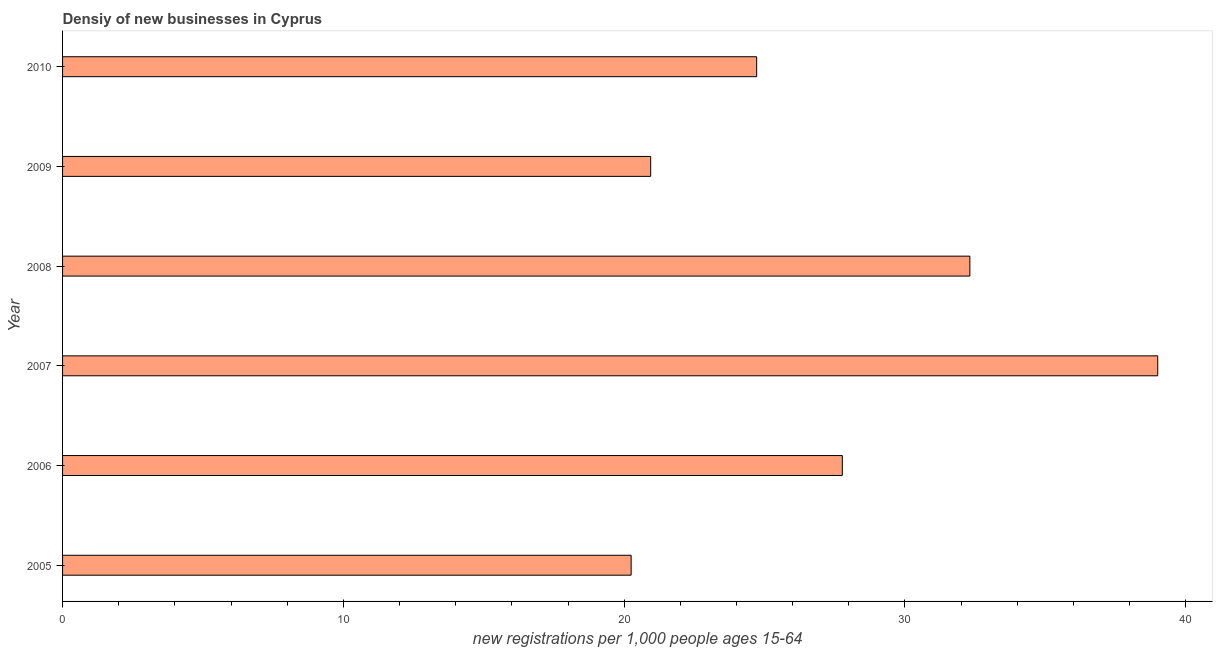What is the title of the graph?
Provide a short and direct response. Densiy of new businesses in Cyprus. What is the label or title of the X-axis?
Your answer should be compact. New registrations per 1,0 people ages 15-64. What is the label or title of the Y-axis?
Offer a terse response. Year. What is the density of new business in 2008?
Provide a succinct answer. 32.31. Across all years, what is the maximum density of new business?
Your response must be concise. 39. Across all years, what is the minimum density of new business?
Your answer should be compact. 20.25. What is the sum of the density of new business?
Your response must be concise. 164.99. What is the difference between the density of new business in 2005 and 2006?
Provide a succinct answer. -7.52. What is the average density of new business per year?
Offer a terse response. 27.5. What is the median density of new business?
Provide a short and direct response. 26.24. What is the ratio of the density of new business in 2005 to that in 2006?
Give a very brief answer. 0.73. Is the density of new business in 2008 less than that in 2010?
Make the answer very short. No. What is the difference between the highest and the second highest density of new business?
Your response must be concise. 6.69. What is the difference between the highest and the lowest density of new business?
Your response must be concise. 18.75. In how many years, is the density of new business greater than the average density of new business taken over all years?
Make the answer very short. 3. Are all the bars in the graph horizontal?
Your answer should be compact. Yes. How many years are there in the graph?
Offer a terse response. 6. What is the difference between two consecutive major ticks on the X-axis?
Keep it short and to the point. 10. Are the values on the major ticks of X-axis written in scientific E-notation?
Offer a very short reply. No. What is the new registrations per 1,000 people ages 15-64 in 2005?
Provide a succinct answer. 20.25. What is the new registrations per 1,000 people ages 15-64 in 2006?
Your response must be concise. 27.77. What is the new registrations per 1,000 people ages 15-64 of 2007?
Keep it short and to the point. 39. What is the new registrations per 1,000 people ages 15-64 of 2008?
Ensure brevity in your answer.  32.31. What is the new registrations per 1,000 people ages 15-64 of 2009?
Make the answer very short. 20.94. What is the new registrations per 1,000 people ages 15-64 of 2010?
Ensure brevity in your answer.  24.72. What is the difference between the new registrations per 1,000 people ages 15-64 in 2005 and 2006?
Offer a very short reply. -7.52. What is the difference between the new registrations per 1,000 people ages 15-64 in 2005 and 2007?
Ensure brevity in your answer.  -18.75. What is the difference between the new registrations per 1,000 people ages 15-64 in 2005 and 2008?
Make the answer very short. -12.06. What is the difference between the new registrations per 1,000 people ages 15-64 in 2005 and 2009?
Give a very brief answer. -0.7. What is the difference between the new registrations per 1,000 people ages 15-64 in 2005 and 2010?
Keep it short and to the point. -4.47. What is the difference between the new registrations per 1,000 people ages 15-64 in 2006 and 2007?
Keep it short and to the point. -11.23. What is the difference between the new registrations per 1,000 people ages 15-64 in 2006 and 2008?
Keep it short and to the point. -4.54. What is the difference between the new registrations per 1,000 people ages 15-64 in 2006 and 2009?
Offer a very short reply. 6.83. What is the difference between the new registrations per 1,000 people ages 15-64 in 2006 and 2010?
Your answer should be compact. 3.05. What is the difference between the new registrations per 1,000 people ages 15-64 in 2007 and 2008?
Give a very brief answer. 6.69. What is the difference between the new registrations per 1,000 people ages 15-64 in 2007 and 2009?
Ensure brevity in your answer.  18.06. What is the difference between the new registrations per 1,000 people ages 15-64 in 2007 and 2010?
Offer a terse response. 14.28. What is the difference between the new registrations per 1,000 people ages 15-64 in 2008 and 2009?
Offer a very short reply. 11.37. What is the difference between the new registrations per 1,000 people ages 15-64 in 2008 and 2010?
Your answer should be compact. 7.59. What is the difference between the new registrations per 1,000 people ages 15-64 in 2009 and 2010?
Provide a short and direct response. -3.77. What is the ratio of the new registrations per 1,000 people ages 15-64 in 2005 to that in 2006?
Keep it short and to the point. 0.73. What is the ratio of the new registrations per 1,000 people ages 15-64 in 2005 to that in 2007?
Make the answer very short. 0.52. What is the ratio of the new registrations per 1,000 people ages 15-64 in 2005 to that in 2008?
Ensure brevity in your answer.  0.63. What is the ratio of the new registrations per 1,000 people ages 15-64 in 2005 to that in 2009?
Your response must be concise. 0.97. What is the ratio of the new registrations per 1,000 people ages 15-64 in 2005 to that in 2010?
Provide a succinct answer. 0.82. What is the ratio of the new registrations per 1,000 people ages 15-64 in 2006 to that in 2007?
Keep it short and to the point. 0.71. What is the ratio of the new registrations per 1,000 people ages 15-64 in 2006 to that in 2008?
Make the answer very short. 0.86. What is the ratio of the new registrations per 1,000 people ages 15-64 in 2006 to that in 2009?
Make the answer very short. 1.33. What is the ratio of the new registrations per 1,000 people ages 15-64 in 2006 to that in 2010?
Your answer should be very brief. 1.12. What is the ratio of the new registrations per 1,000 people ages 15-64 in 2007 to that in 2008?
Keep it short and to the point. 1.21. What is the ratio of the new registrations per 1,000 people ages 15-64 in 2007 to that in 2009?
Your answer should be compact. 1.86. What is the ratio of the new registrations per 1,000 people ages 15-64 in 2007 to that in 2010?
Your answer should be very brief. 1.58. What is the ratio of the new registrations per 1,000 people ages 15-64 in 2008 to that in 2009?
Your answer should be very brief. 1.54. What is the ratio of the new registrations per 1,000 people ages 15-64 in 2008 to that in 2010?
Provide a short and direct response. 1.31. What is the ratio of the new registrations per 1,000 people ages 15-64 in 2009 to that in 2010?
Your answer should be very brief. 0.85. 